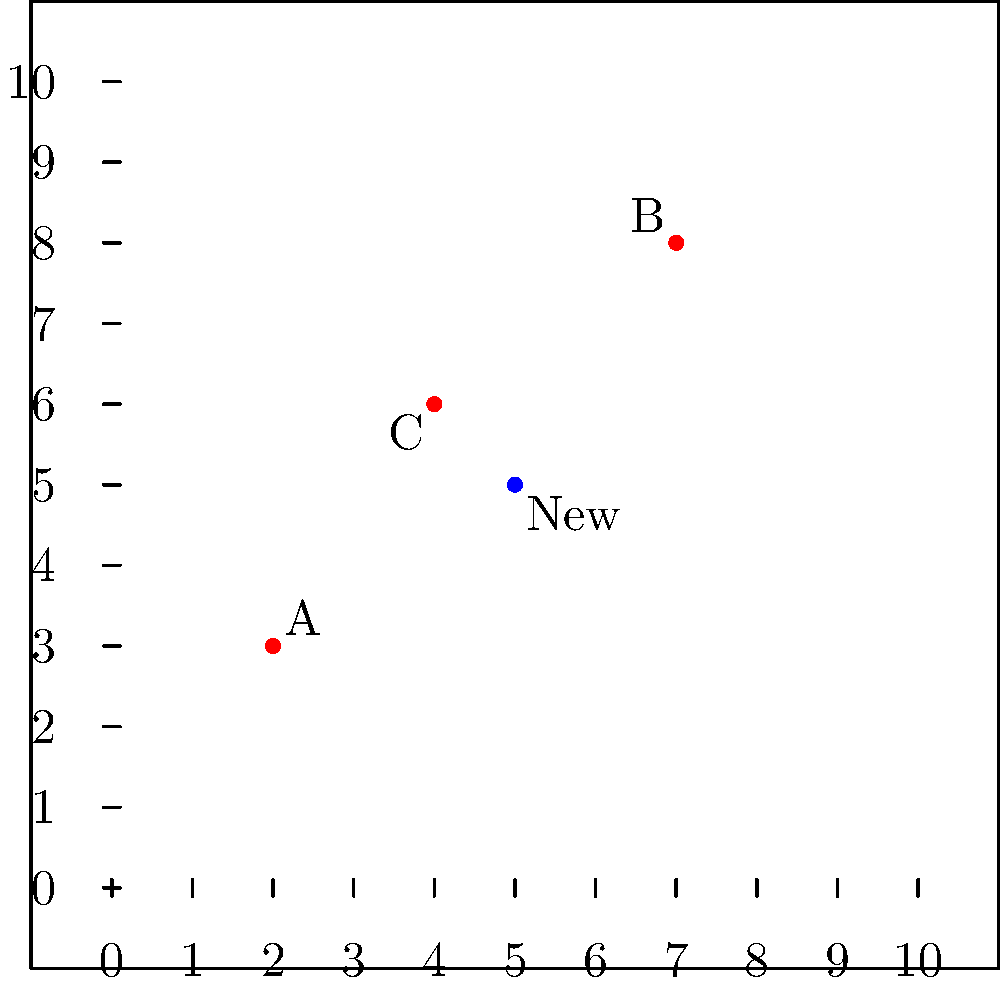As a health-care worker in Slovakia, you're tasked with optimizing the coverage of health clinics in a region. The existing clinics A, B, and C are located at coordinates (2,3), (7,8), and (4,6) respectively on a 10x10 km grid. A new clinic is proposed at (5,5). Calculate the sum of the distances from the new clinic to all existing clinics using the distance formula. Round your answer to the nearest tenth of a kilometer. To solve this problem, we'll follow these steps:

1) Recall the distance formula between two points $(x_1, y_1)$ and $(x_2, y_2)$:
   $$d = \sqrt{(x_2-x_1)^2 + (y_2-y_1)^2}$$

2) Calculate the distance from the new clinic (5,5) to each existing clinic:

   a) Distance to A (2,3):
      $$d_A = \sqrt{(5-2)^2 + (5-3)^2} = \sqrt{3^2 + 2^2} = \sqrt{13} \approx 3.6$$

   b) Distance to B (7,8):
      $$d_B = \sqrt{(5-7)^2 + (5-8)^2} = \sqrt{(-2)^2 + (-3)^2} = \sqrt{13} \approx 3.6$$

   c) Distance to C (4,6):
      $$d_C = \sqrt{(5-4)^2 + (5-6)^2} = \sqrt{1^2 + (-1)^2} = \sqrt{2} \approx 1.4$$

3) Sum up all the distances:
   $$\text{Total distance} = d_A + d_B + d_C \approx 3.6 + 3.6 + 1.4 = 8.6$$

4) Round to the nearest tenth:
   8.6 km

This sum represents the total distance the new clinic is from all existing clinics, which can be used to assess the new clinic's position in relation to the existing network.
Answer: 8.6 km 